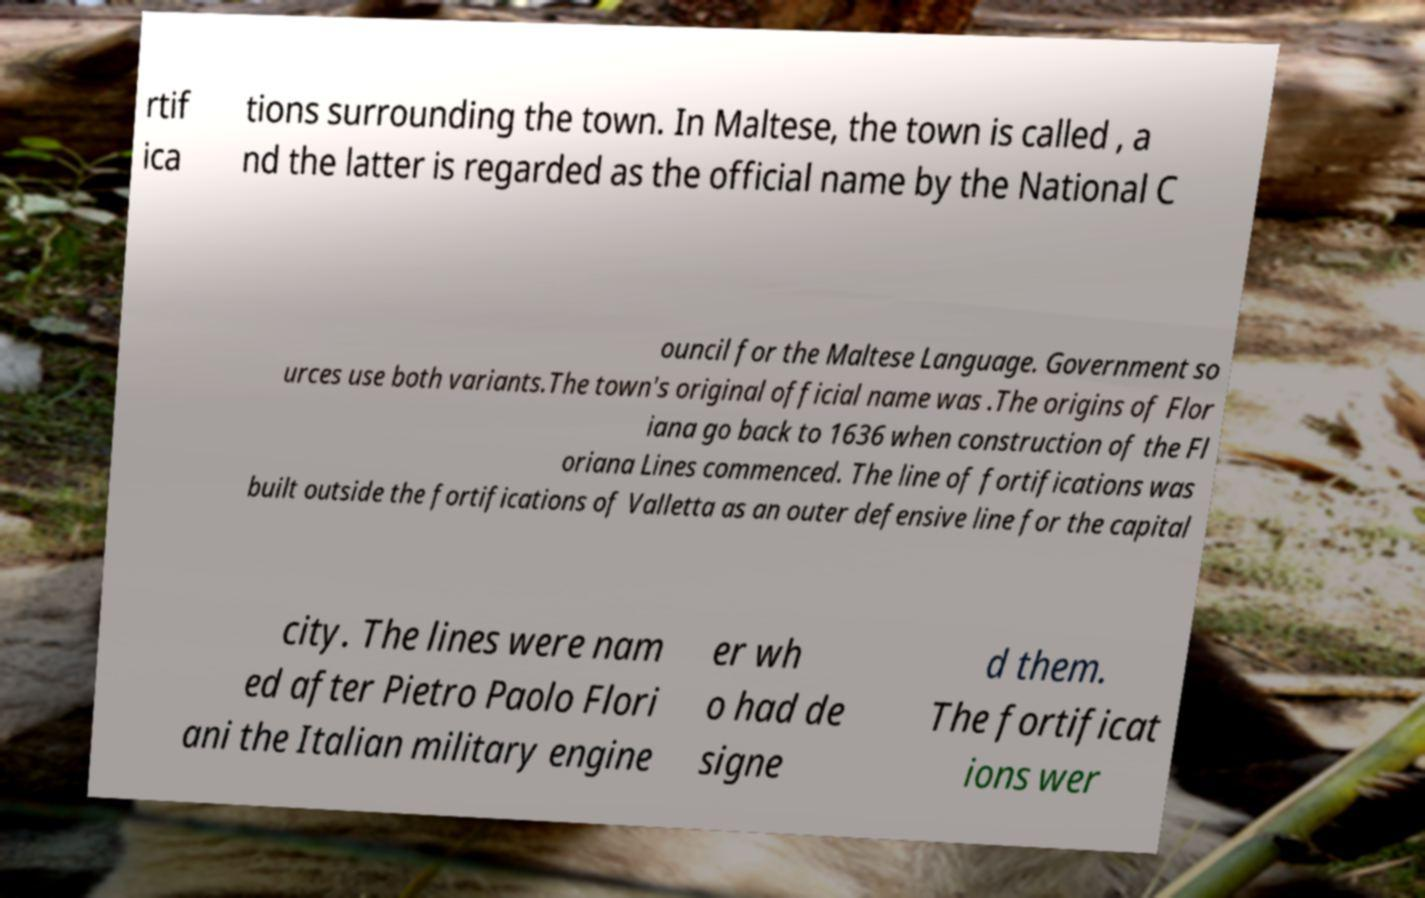Could you extract and type out the text from this image? rtif ica tions surrounding the town. In Maltese, the town is called , a nd the latter is regarded as the official name by the National C ouncil for the Maltese Language. Government so urces use both variants.The town's original official name was .The origins of Flor iana go back to 1636 when construction of the Fl oriana Lines commenced. The line of fortifications was built outside the fortifications of Valletta as an outer defensive line for the capital city. The lines were nam ed after Pietro Paolo Flori ani the Italian military engine er wh o had de signe d them. The fortificat ions wer 